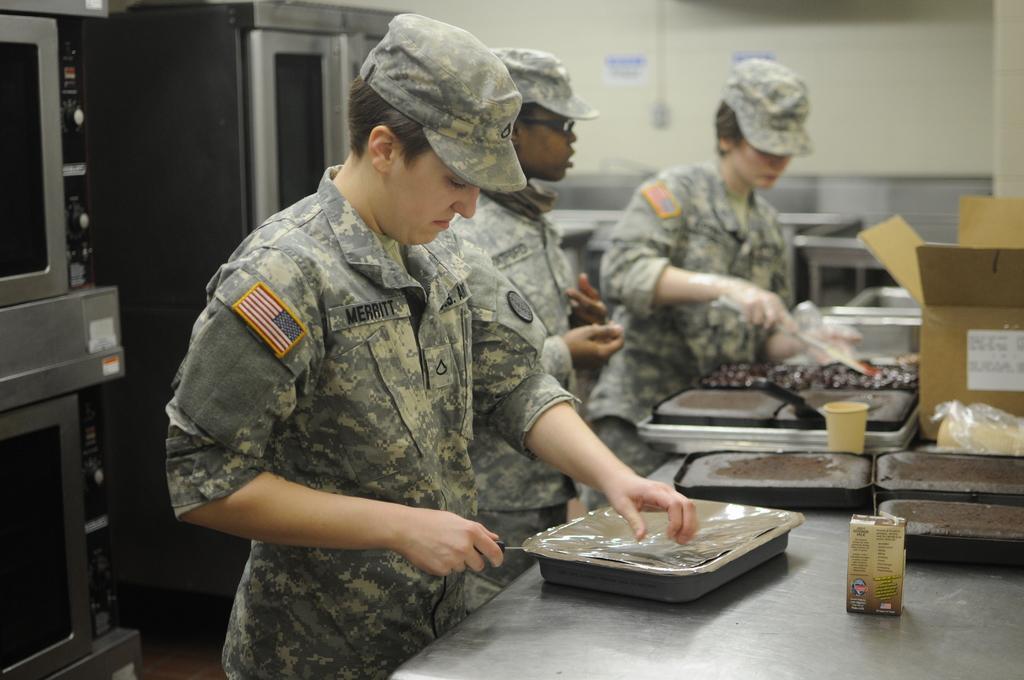Could you give a brief overview of what you see in this image? In the picture i can see three persons wearing camouflage dress making some food item in the kitchen, there are some pans, bottles, cardboard boxes on surface, on left side of the picture there is microwave oven, some object and there is a wall. 